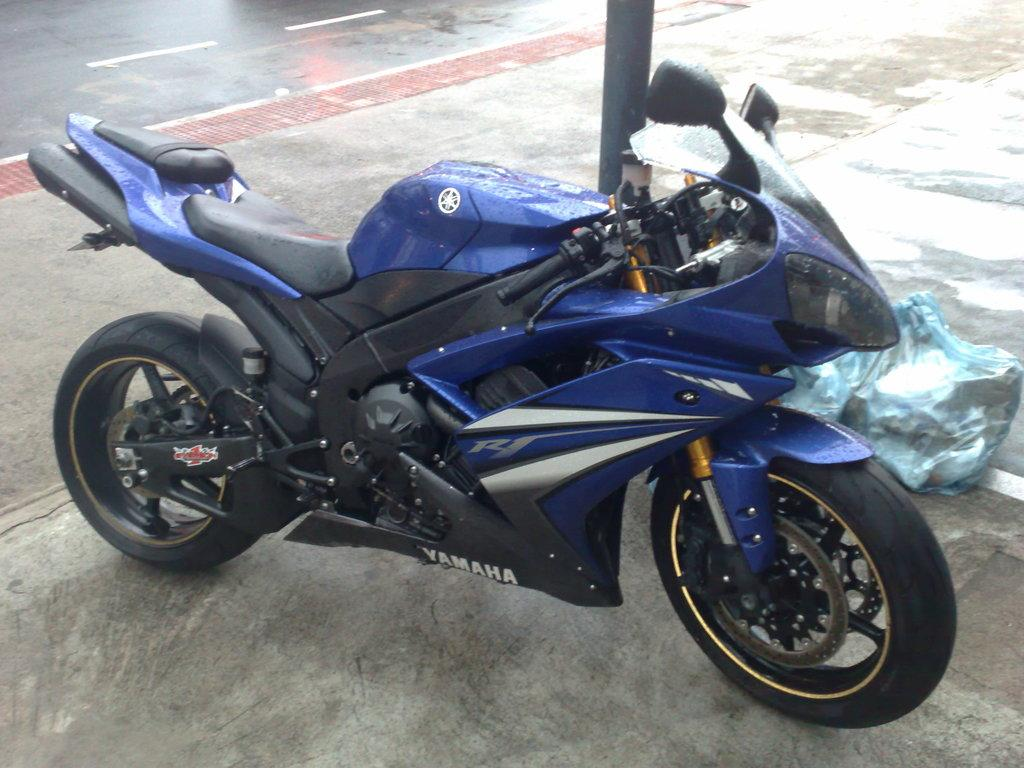What type of vehicle is in the image? There is a blue motorbike in the image. Where is the motorbike located? The motorbike is parked on a path. What can be seen in the background of the image? There is a pole and a road visible in the background of the image. How much profit does the pencil generate in the image? There is no pencil present in the image, so it is not possible to determine any profit generated. 